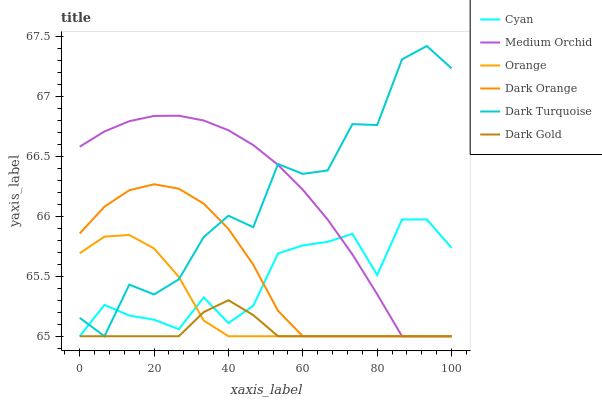Does Dark Gold have the minimum area under the curve?
Answer yes or no. Yes. Does Medium Orchid have the maximum area under the curve?
Answer yes or no. Yes. Does Dark Turquoise have the minimum area under the curve?
Answer yes or no. No. Does Dark Turquoise have the maximum area under the curve?
Answer yes or no. No. Is Dark Gold the smoothest?
Answer yes or no. Yes. Is Dark Turquoise the roughest?
Answer yes or no. Yes. Is Dark Turquoise the smoothest?
Answer yes or no. No. Is Dark Gold the roughest?
Answer yes or no. No. Does Dark Orange have the lowest value?
Answer yes or no. Yes. Does Dark Turquoise have the highest value?
Answer yes or no. Yes. Does Dark Gold have the highest value?
Answer yes or no. No. Does Cyan intersect Orange?
Answer yes or no. Yes. Is Cyan less than Orange?
Answer yes or no. No. Is Cyan greater than Orange?
Answer yes or no. No. 